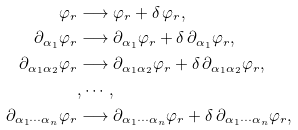Convert formula to latex. <formula><loc_0><loc_0><loc_500><loc_500>\varphi _ { r } & \longrightarrow \varphi _ { r } + \delta \, \varphi _ { r } , \\ \partial _ { \alpha _ { 1 } } \varphi _ { r } & \longrightarrow \partial _ { \alpha _ { 1 } } \varphi _ { r } + \delta \, \partial _ { \alpha _ { 1 } } \varphi _ { r } , \\ \partial _ { \alpha _ { 1 } \alpha _ { 2 } } \varphi _ { r } & \longrightarrow \partial _ { \alpha _ { 1 } \alpha _ { 2 } } \varphi _ { r } + \delta \, \partial _ { \alpha _ { 1 } \alpha _ { 2 } } \varphi _ { r } , \\ & , \cdots , \\ \partial _ { \alpha _ { 1 } \cdots \alpha _ { n } } \varphi _ { r } & \longrightarrow \partial _ { \alpha _ { 1 } \cdots \alpha _ { n } } \varphi _ { r } + \delta \, \partial _ { \alpha _ { 1 } \cdots \alpha _ { n } } \varphi _ { r } ,</formula> 